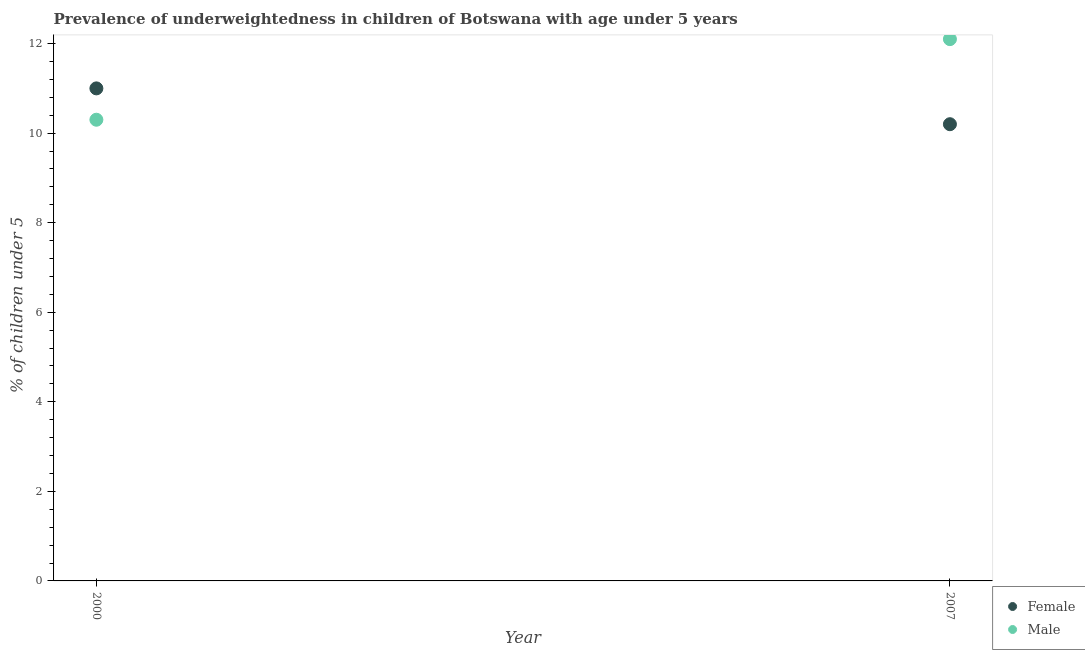How many different coloured dotlines are there?
Your answer should be very brief. 2. What is the percentage of underweighted female children in 2007?
Give a very brief answer. 10.2. Across all years, what is the maximum percentage of underweighted female children?
Your response must be concise. 11. Across all years, what is the minimum percentage of underweighted male children?
Your response must be concise. 10.3. In which year was the percentage of underweighted female children maximum?
Provide a short and direct response. 2000. In which year was the percentage of underweighted female children minimum?
Ensure brevity in your answer.  2007. What is the total percentage of underweighted female children in the graph?
Provide a succinct answer. 21.2. What is the difference between the percentage of underweighted female children in 2000 and that in 2007?
Provide a succinct answer. 0.8. What is the difference between the percentage of underweighted male children in 2007 and the percentage of underweighted female children in 2000?
Provide a succinct answer. 1.1. What is the average percentage of underweighted male children per year?
Your response must be concise. 11.2. In the year 2007, what is the difference between the percentage of underweighted male children and percentage of underweighted female children?
Your response must be concise. 1.9. What is the ratio of the percentage of underweighted female children in 2000 to that in 2007?
Your answer should be compact. 1.08. In how many years, is the percentage of underweighted male children greater than the average percentage of underweighted male children taken over all years?
Your answer should be very brief. 1. Is the percentage of underweighted male children strictly greater than the percentage of underweighted female children over the years?
Provide a succinct answer. No. Is the percentage of underweighted male children strictly less than the percentage of underweighted female children over the years?
Your response must be concise. No. How many dotlines are there?
Provide a succinct answer. 2. How many years are there in the graph?
Ensure brevity in your answer.  2. Does the graph contain grids?
Your response must be concise. No. How many legend labels are there?
Provide a succinct answer. 2. How are the legend labels stacked?
Offer a very short reply. Vertical. What is the title of the graph?
Your answer should be compact. Prevalence of underweightedness in children of Botswana with age under 5 years. Does "Age 15+" appear as one of the legend labels in the graph?
Ensure brevity in your answer.  No. What is the label or title of the X-axis?
Your answer should be compact. Year. What is the label or title of the Y-axis?
Your answer should be very brief.  % of children under 5. What is the  % of children under 5 in Female in 2000?
Offer a terse response. 11. What is the  % of children under 5 of Male in 2000?
Your answer should be very brief. 10.3. What is the  % of children under 5 in Female in 2007?
Ensure brevity in your answer.  10.2. What is the  % of children under 5 in Male in 2007?
Your answer should be very brief. 12.1. Across all years, what is the maximum  % of children under 5 in Female?
Make the answer very short. 11. Across all years, what is the maximum  % of children under 5 of Male?
Provide a short and direct response. 12.1. Across all years, what is the minimum  % of children under 5 in Female?
Offer a very short reply. 10.2. Across all years, what is the minimum  % of children under 5 of Male?
Make the answer very short. 10.3. What is the total  % of children under 5 of Female in the graph?
Keep it short and to the point. 21.2. What is the total  % of children under 5 in Male in the graph?
Your answer should be compact. 22.4. What is the difference between the  % of children under 5 of Male in 2000 and that in 2007?
Your answer should be compact. -1.8. What is the average  % of children under 5 in Female per year?
Your answer should be very brief. 10.6. In the year 2007, what is the difference between the  % of children under 5 in Female and  % of children under 5 in Male?
Provide a succinct answer. -1.9. What is the ratio of the  % of children under 5 in Female in 2000 to that in 2007?
Offer a terse response. 1.08. What is the ratio of the  % of children under 5 of Male in 2000 to that in 2007?
Keep it short and to the point. 0.85. What is the difference between the highest and the second highest  % of children under 5 in Female?
Your answer should be very brief. 0.8. What is the difference between the highest and the lowest  % of children under 5 of Female?
Provide a succinct answer. 0.8. 